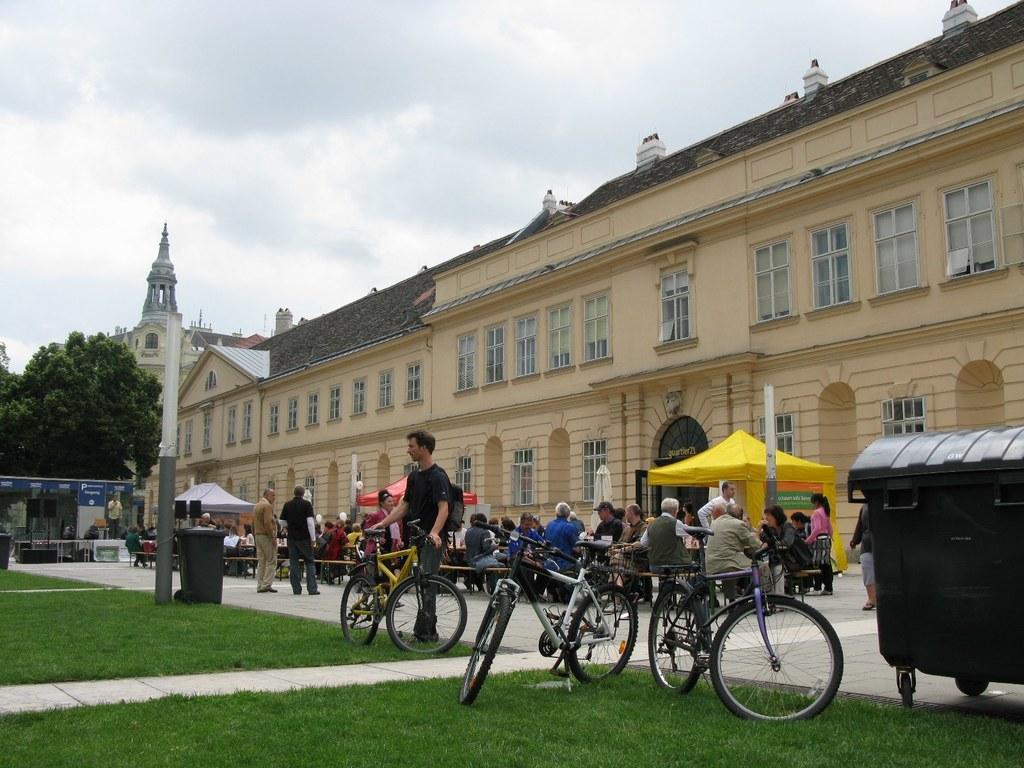In one or two sentences, can you explain what this image depicts? In this picture we can see the grass, bicycles, bins, bag, tents, benches, posters, trees, buildings, windows, curtains, poles and a group of people where some are standing on the ground and some are sitting and in the background we can see the sky with clouds. 